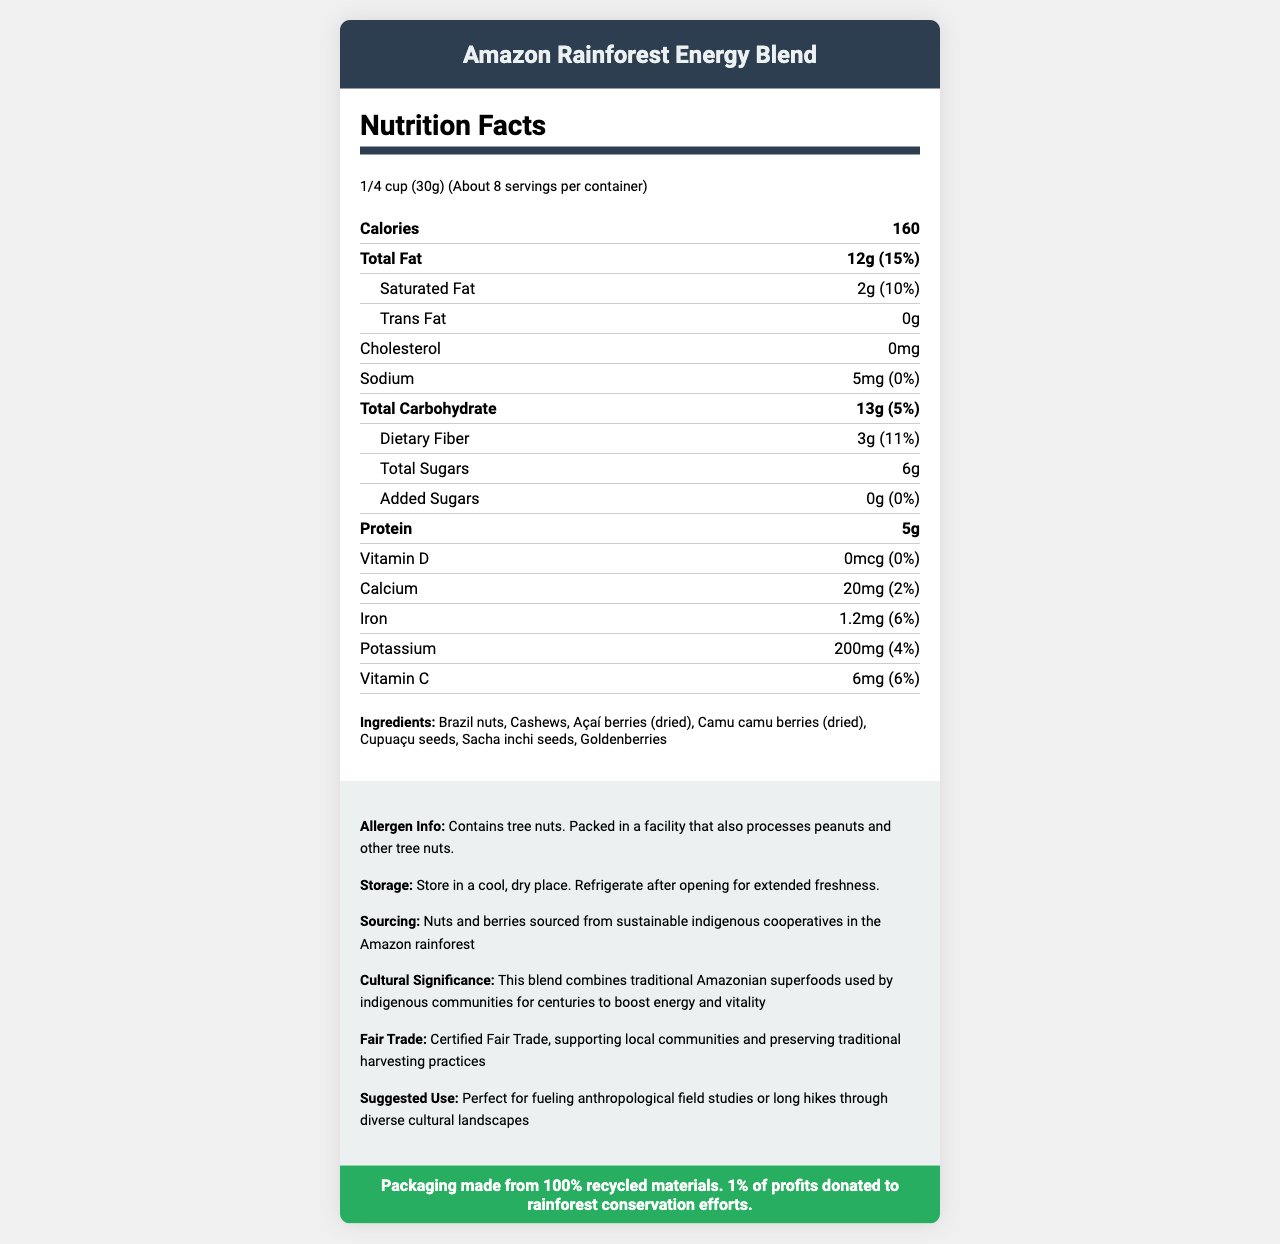What is the serving size of the Amazon Rainforest Energy Blend? The serving size is listed as "1/4 cup (30g)" in the document.
Answer: 1/4 cup (30g) How many calories are in one serving of the Amazon Rainforest Energy Blend? The document states that each serving contains 160 calories.
Answer: 160 List the main ingredients of the Amazon Rainforest Energy Blend. The ingredients are listed in the ingredients section of the document.
Answer: Brazil nuts, Cashews, Açaí berries (dried), Camu camu berries (dried), Cupuaçu seeds, Sacha inchi seeds, Goldenberries What is the recommended storage instruction for the product after opening? The storage instructions mention to "Refrigerate after opening for extended freshness."
Answer: Refrigerate after opening for extended freshness Name one of the traditional uses of the blend by indigenous communities. The document mentions that this blend is used by indigenous communities to "boost energy and vitality."
Answer: Boost energy and vitality How many grams of protein are in one serving? The document states that one serving contains 5g of protein.
Answer: 5g What is the cholesterol content in one serving of the trail mix? The document lists the cholesterol content as "0mg."
Answer: 0mg How much dietary fiber is in each serving? The dietary fiber content per serving is listed as 3g in the document.
Answer: 3g Is the packaging for the Amazon Rainforest Energy Blend sustainable? The document states that the packaging is made from 100% recycled materials.
Answer: Yes How many servings are in one container of the Amazon Rainforest Energy Blend? A. About 4 B. About 6 C. About 8 The document states that there are about 8 servings per container.
Answer: C. About 8 Which of the following vitamins are present in the trail mix? A. Vitamin D B. Vitamin A C. Vitamin C The document lists Vitamin C with an amount of 6mg and a daily value of 6%.
Answer: C. Vitamin C Which nut is not included in the Amazon Rainforest Energy Blend? A. Almonds B. Cashews C. Brazil nuts The list of ingredients includes Cashews and Brazil nuts but does not mention Almonds.
Answer: A. Almonds Is the product certified fair trade? The document indicates that the blend is "Certified Fair Trade."
Answer: Yes Summarize the main idea of the document. The main idea of the document is to offer comprehensive information on the Amazon Rainforest Energy Blend, including its serving size, calorie content, nutrients, ingredients, storage instructions, and its cultural and environmental significance.
Answer: The document provides nutritional information, ingredients, and additional details about the Amazon Rainforest Energy Blend, highlighting its nutritional benefits, fair trade certification, and sustainable sourcing. Can this trail mix be used as a dietary supplement for vitamin D? The document states that the trail mix contains 0mcg of Vitamin D, which means it does not contribute to the daily value of Vitamin D.
Answer: No What is the exact percentage of daily value for iron in one serving of the Amazon Rainforest Energy Blend? The document lists the iron content as 1.2mg, providing 6% of the daily value.
Answer: 6% Describe the allergen information provided for the Amazon Rainforest Energy Blend. The document mentions that the blend "Contains tree nuts" and is "Packed in a facility that also processes peanuts and other tree nuts."
Answer: Contains tree nuts. Packed in a facility that also processes peanuts and other tree nuts. How many grams of added sugars are present in one serving of the blend? The document lists the amount of added sugars as 0g.
Answer: 0g From where are the nuts and berries in this blend sourced? The document states that the nuts and berries are sourced from sustainable indigenous cooperatives in the Amazon rainforest.
Answer: Sustainable indigenous cooperatives in the Amazon rainforest What are the benefits mentioned of consuming this Amazon Rainforest Energy Blend? The document mentions that the traditional use of the blend by indigenous communities is to "boost energy and vitality."
Answer: Boost energy and vitality How much calcium is found in one serving of the Amazon Rainforest Energy Blend? The document lists the calcium content as 20mg per serving.
Answer: 20mg What is the sodium content per serving of this trail mix? The sodium content per serving is listed as 5mg.
Answer: 5mg What is the total carbohydrate content and its daily value percentage in one serving? The document states the total carbohydrate content as 13g, which is 5% of the daily value.
Answer: 13g, 5% How could the Amazon Rainforest Energy Blend be suitable for an Anthropology student like you? The document suggests using the blend for "fueling anthropological field studies or long hikes through diverse cultural landscapes."
Answer: Perfect for fueling anthropological field studies or long hikes through diverse cultural landscapes What is the cultural significance of the ingredients used in the Amazon Rainforest Energy Blend? The document mentions that the blend combines traditional Amazonian superfoods used by indigenous communities to boost energy and vitality.
Answer: This blend combines traditional Amazonian superfoods used by indigenous communities for centuries to boost energy and vitality. Which local communities benefit from the fair trade certification of the product? The document indicates that the product is fair trade certified but does not specify which local communities benefit from this certification.
Answer: Cannot be determined 